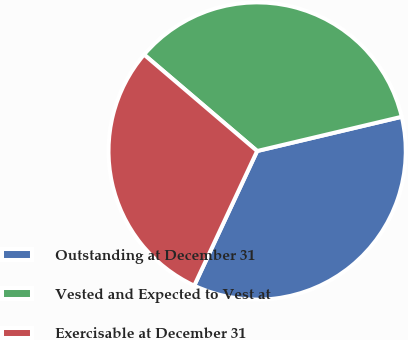Convert chart. <chart><loc_0><loc_0><loc_500><loc_500><pie_chart><fcel>Outstanding at December 31<fcel>Vested and Expected to Vest at<fcel>Exercisable at December 31<nl><fcel>35.66%<fcel>35.06%<fcel>29.28%<nl></chart> 